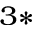Convert formula to latex. <formula><loc_0><loc_0><loc_500><loc_500>^ { 3 \ast }</formula> 